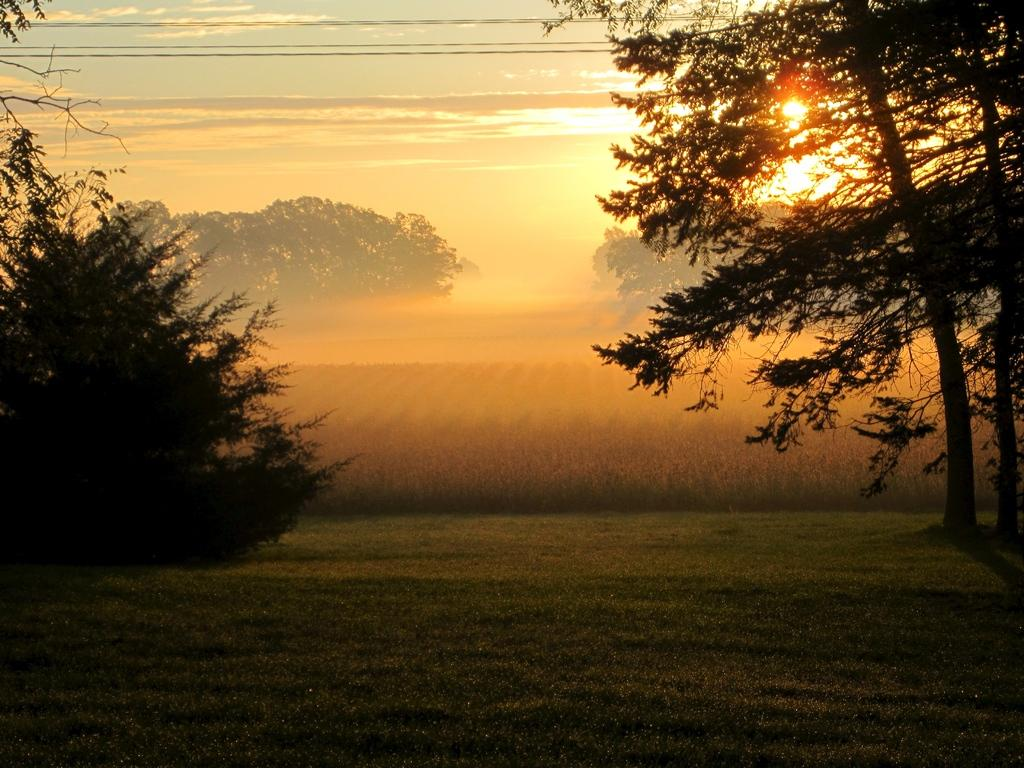What type of natural vegetation can be seen in the image? There are trees in the image. What celestial body is visible in the background of the image? The sun is visible in the background of the image. How would you describe the color of the sky in the image? The sky has a combination of white and blue colors. How much money is being exchanged between the trees in the image? There is no money exchange happening between the trees in the image, as trees are not capable of such transactions. 